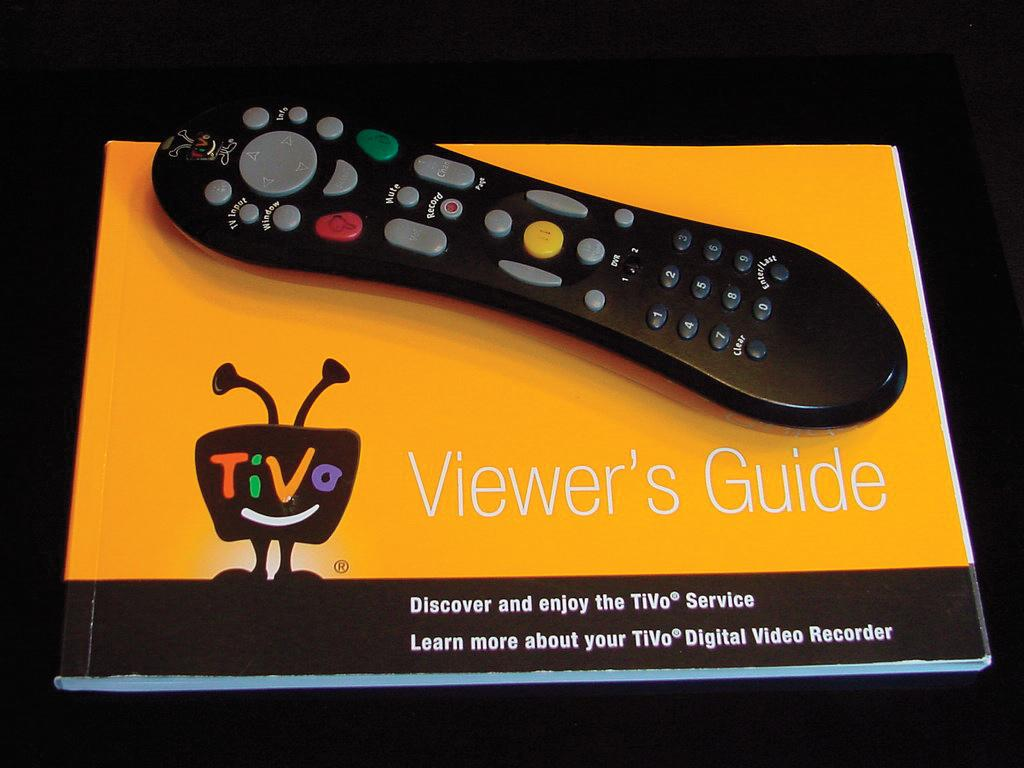Provide a one-sentence caption for the provided image. A remote control on top of a Viewer's Guide booklet for Tivo. 